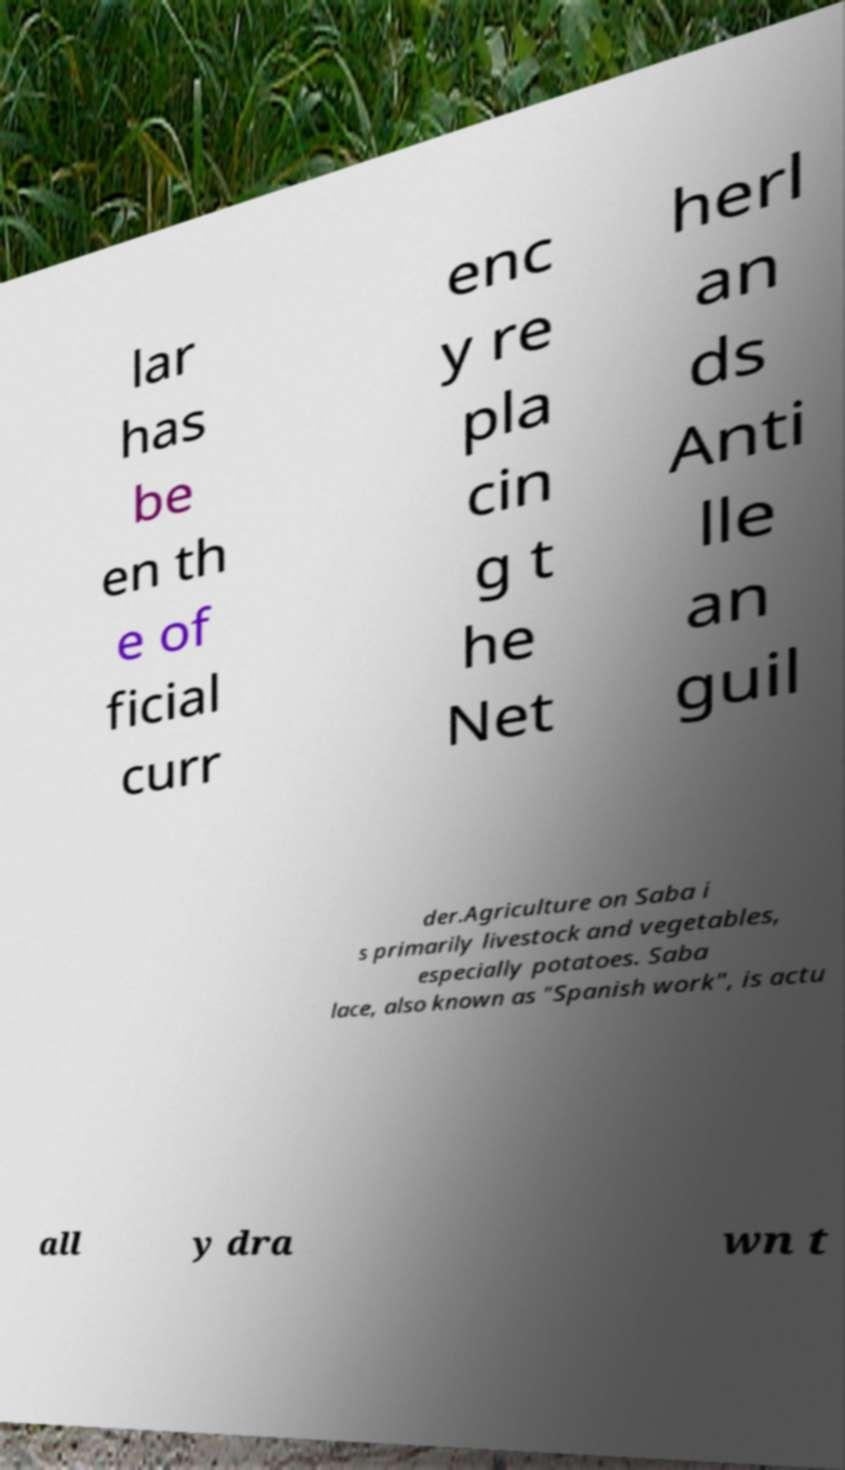Please read and relay the text visible in this image. What does it say? lar has be en th e of ficial curr enc y re pla cin g t he Net herl an ds Anti lle an guil der.Agriculture on Saba i s primarily livestock and vegetables, especially potatoes. Saba lace, also known as "Spanish work", is actu all y dra wn t 